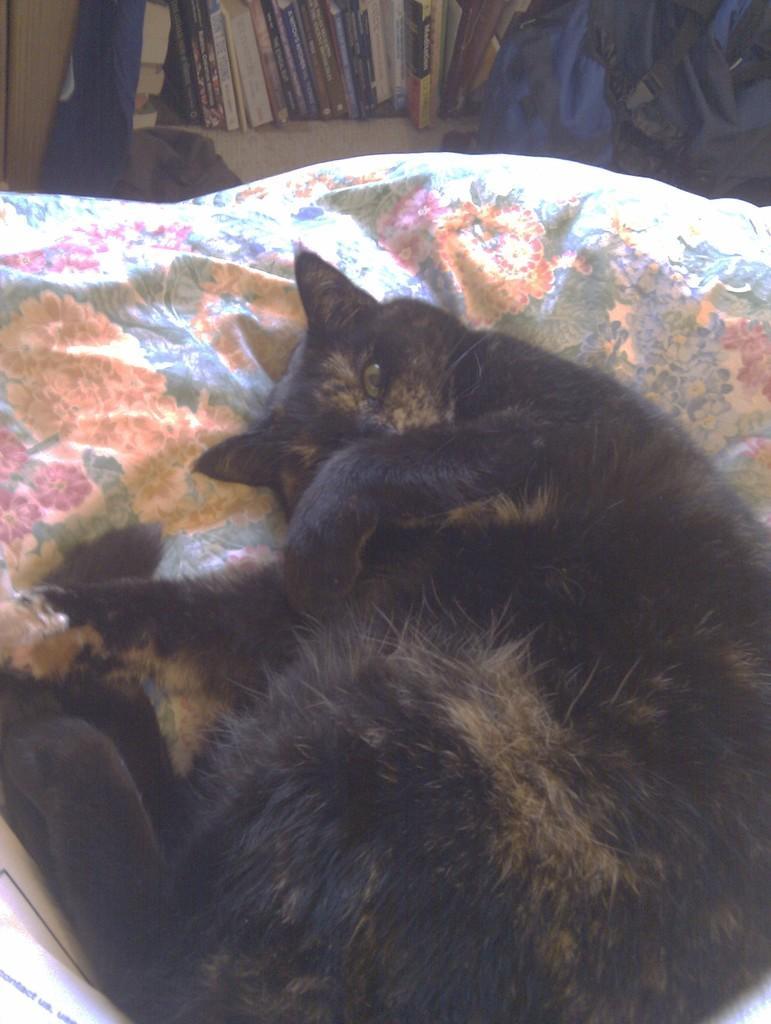How would you summarize this image in a sentence or two? In the foreground of this image, there is a black cat lying on the cloth. In the background, there is a bag, books in the shelf and seems like a flag on the top left corner. 